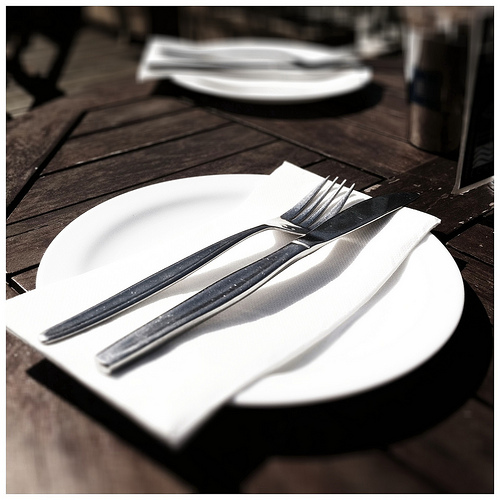<image>
Is there a knife on the napkin? Yes. Looking at the image, I can see the knife is positioned on top of the napkin, with the napkin providing support. Is there a plate on the table? Yes. Looking at the image, I can see the plate is positioned on top of the table, with the table providing support. Is there a knife on the table? No. The knife is not positioned on the table. They may be near each other, but the knife is not supported by or resting on top of the table. 